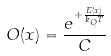<formula> <loc_0><loc_0><loc_500><loc_500>O ( x ) = \frac { e ^ { + \frac { E ( x ) } { k _ { Q } T } } } { C }</formula> 